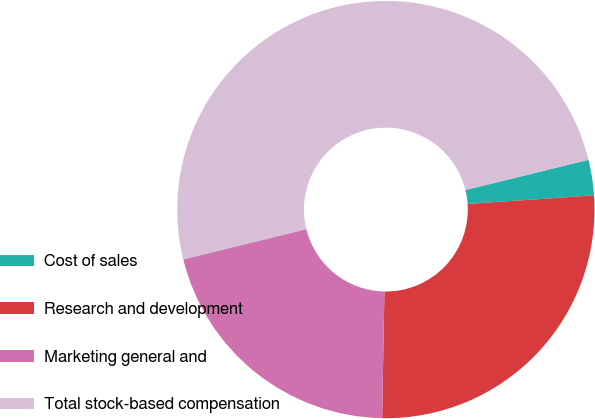<chart> <loc_0><loc_0><loc_500><loc_500><pie_chart><fcel>Cost of sales<fcel>Research and development<fcel>Marketing general and<fcel>Total stock-based compensation<nl><fcel>2.75%<fcel>26.37%<fcel>20.88%<fcel>50.0%<nl></chart> 